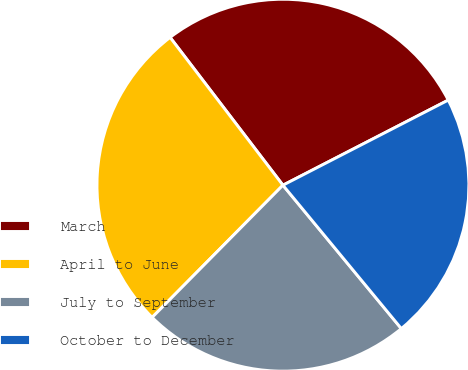Convert chart. <chart><loc_0><loc_0><loc_500><loc_500><pie_chart><fcel>March<fcel>April to June<fcel>July to September<fcel>October to December<nl><fcel>27.81%<fcel>27.21%<fcel>23.4%<fcel>21.58%<nl></chart> 